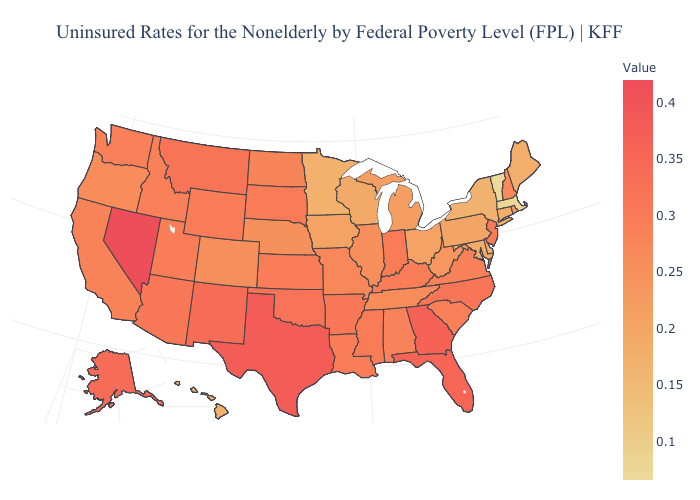Is the legend a continuous bar?
Quick response, please. Yes. Among the states that border Utah , does Arizona have the highest value?
Write a very short answer. No. Is the legend a continuous bar?
Write a very short answer. Yes. Among the states that border Kentucky , does Indiana have the highest value?
Short answer required. Yes. Which states hav the highest value in the South?
Keep it brief. Texas. Among the states that border Louisiana , which have the highest value?
Concise answer only. Texas. 